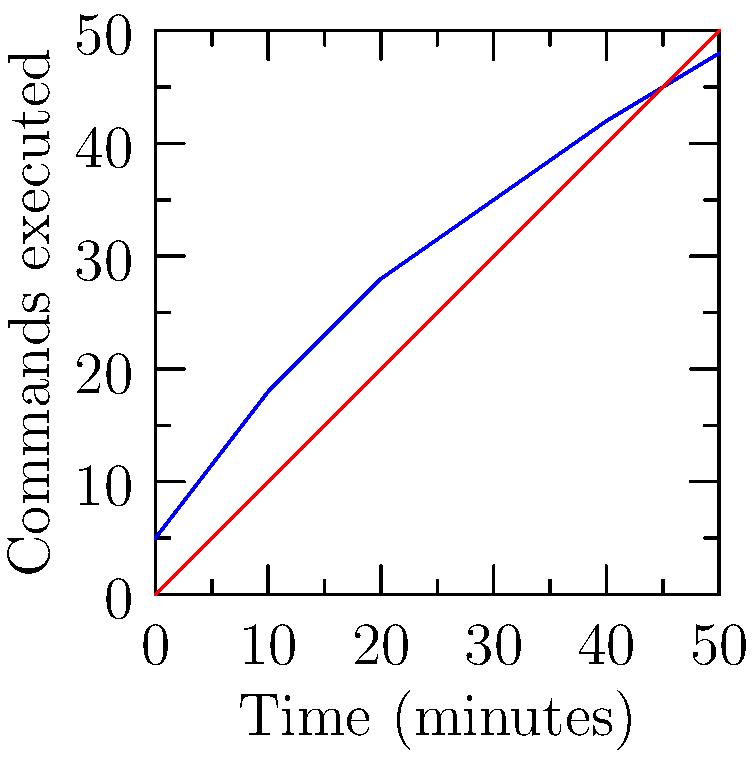In a MOBA game, players were tested on their ability to execute game commands using two different keyboard layouts: QWERTY and an ideal layout. The graph shows the number of commands executed over time for the QWERTY layout compared to an ideal scenario. Based on the data, what can we conclude about the efficiency of the QWERTY layout for executing game commands in this MOBA? To analyze the efficiency of the QWERTY layout for executing game commands, we need to compare it to the ideal scenario:

1. Observe the two lines on the graph:
   - Red line represents the ideal scenario
   - Blue line represents the QWERTY layout performance

2. Compare the slopes of the lines:
   - The ideal scenario (red) has a constant slope, indicating consistent command execution
   - The QWERTY layout (blue) has a varying slope, initially steeper but then flattening out

3. Analyze the differences:
   - At the beginning (0-10 minutes), QWERTY performance is close to ideal
   - As time progresses (10-50 minutes), QWERTY falls behind the ideal scenario

4. Calculate the final difference:
   - At 50 minutes, ideal scenario: 50 commands
   - At 50 minutes, QWERTY layout: 48 commands
   - Difference: 50 - 48 = 2 commands

5. Interpret the results:
   - QWERTY layout is initially efficient but becomes less effective over time
   - The difference of 2 commands after 50 minutes suggests a slight inefficiency

Conclusion: The QWERTY layout is reasonably efficient for executing game commands in this MOBA, but it shows a small decrease in performance over time compared to an ideal layout.
Answer: Reasonably efficient, with slight performance decrease over time 